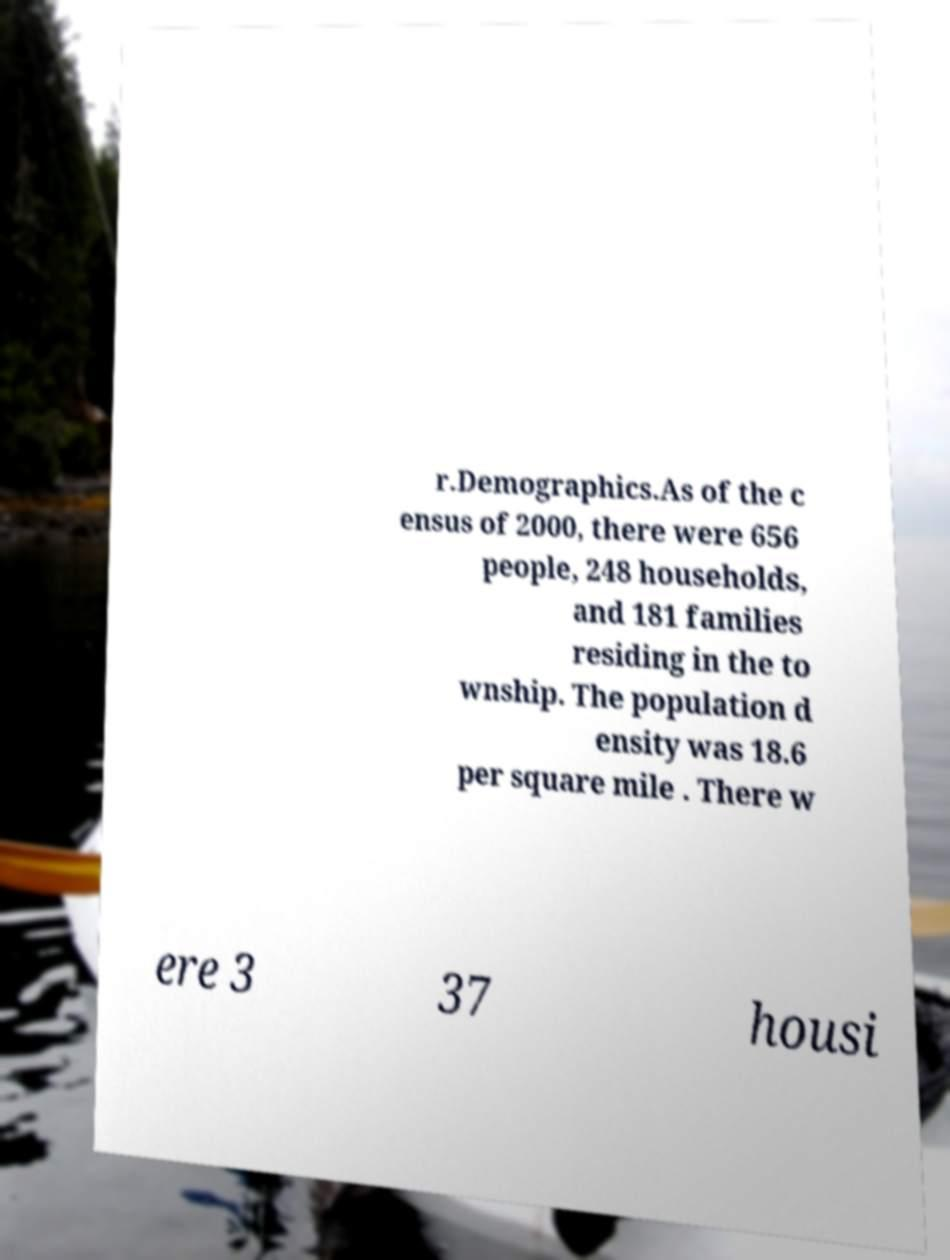Please read and relay the text visible in this image. What does it say? r.Demographics.As of the c ensus of 2000, there were 656 people, 248 households, and 181 families residing in the to wnship. The population d ensity was 18.6 per square mile . There w ere 3 37 housi 